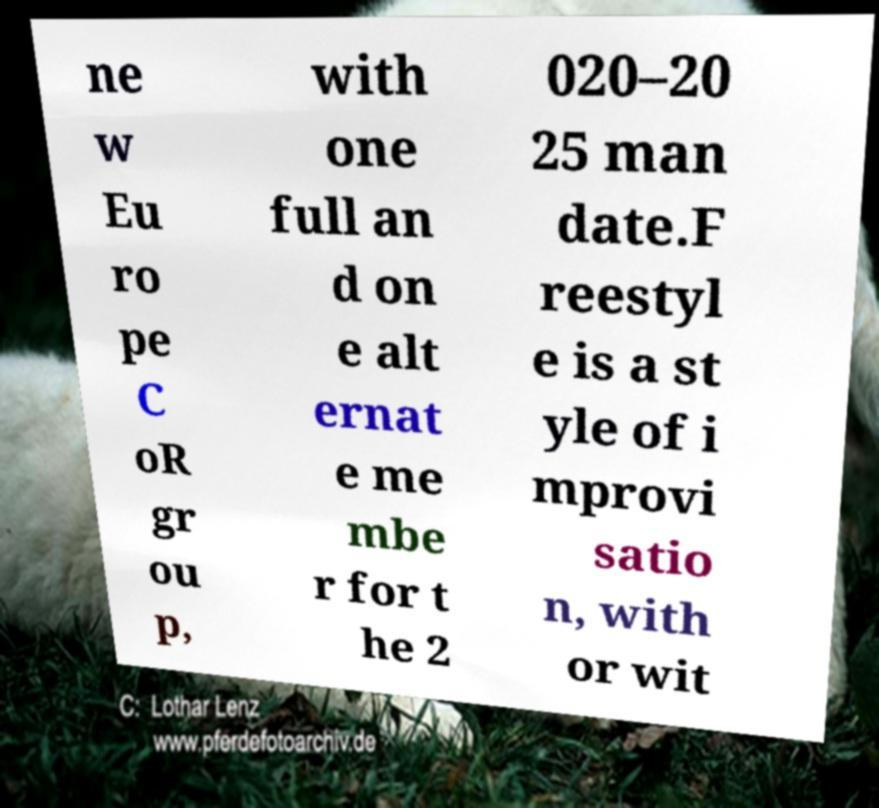Can you accurately transcribe the text from the provided image for me? ne w Eu ro pe C oR gr ou p, with one full an d on e alt ernat e me mbe r for t he 2 020–20 25 man date.F reestyl e is a st yle of i mprovi satio n, with or wit 